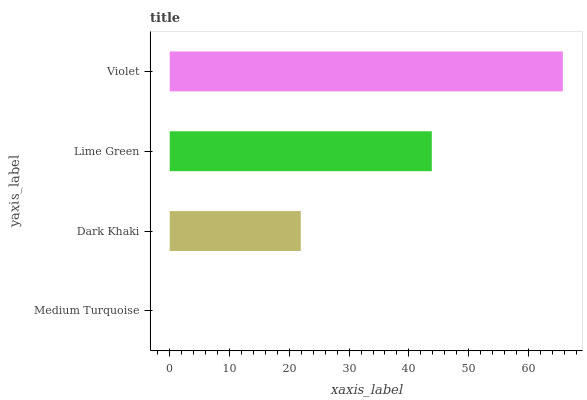Is Medium Turquoise the minimum?
Answer yes or no. Yes. Is Violet the maximum?
Answer yes or no. Yes. Is Dark Khaki the minimum?
Answer yes or no. No. Is Dark Khaki the maximum?
Answer yes or no. No. Is Dark Khaki greater than Medium Turquoise?
Answer yes or no. Yes. Is Medium Turquoise less than Dark Khaki?
Answer yes or no. Yes. Is Medium Turquoise greater than Dark Khaki?
Answer yes or no. No. Is Dark Khaki less than Medium Turquoise?
Answer yes or no. No. Is Lime Green the high median?
Answer yes or no. Yes. Is Dark Khaki the low median?
Answer yes or no. Yes. Is Medium Turquoise the high median?
Answer yes or no. No. Is Lime Green the low median?
Answer yes or no. No. 